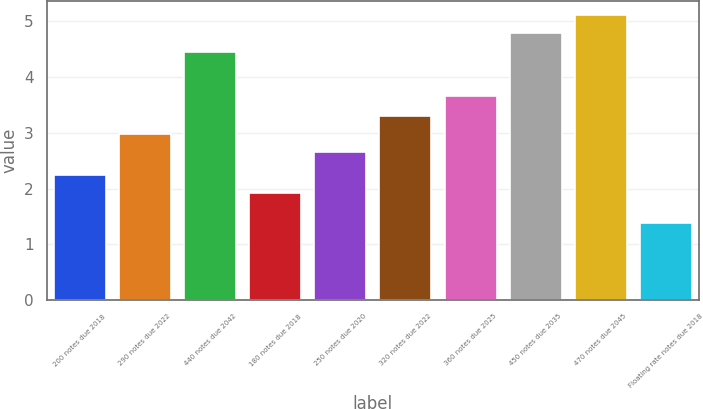<chart> <loc_0><loc_0><loc_500><loc_500><bar_chart><fcel>200 notes due 2018<fcel>290 notes due 2022<fcel>440 notes due 2042<fcel>180 notes due 2018<fcel>250 notes due 2020<fcel>320 notes due 2022<fcel>360 notes due 2025<fcel>450 notes due 2035<fcel>470 notes due 2045<fcel>Floating rate notes due 2018<nl><fcel>2.25<fcel>2.98<fcel>4.46<fcel>1.92<fcel>2.65<fcel>3.31<fcel>3.66<fcel>4.79<fcel>5.12<fcel>1.38<nl></chart> 